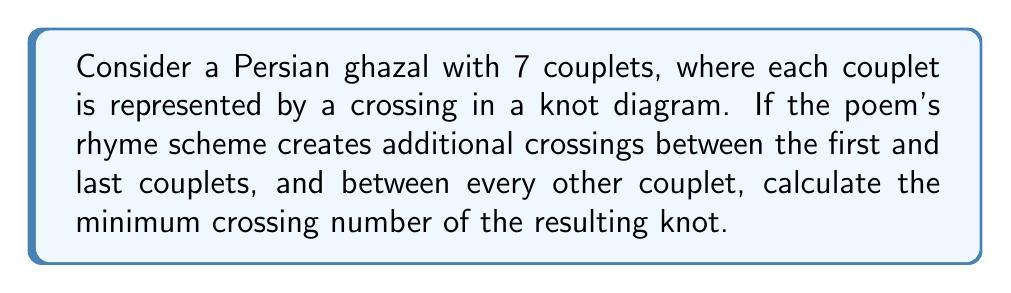Solve this math problem. Let's approach this step-by-step:

1) First, we need to understand the structure of the knot based on the poem:
   - There are 7 couplets, each represented by a crossing.
   - Additional crossings occur between the first and last couplets, and between every other couplet.

2) Let's count the crossings:
   - 7 crossings from the couplets themselves.
   - 1 crossing between the first and last couplet.
   - Crossings between every other couplet:
     There are 3 such additional crossings (1-3, 3-5, 5-7).

3) So far, we have: $7 + 1 + 3 = 11$ crossings.

4) However, the question asks for the minimum crossing number. In knot theory, the minimum crossing number is the smallest number of crossings that can be achieved for a given knot through any possible deformation without cutting the knot.

5) In this case, the structure of the poem creates a relatively simple knot. The crossings between every other couplet can be visualized as creating a spiral-like structure.

6) Given this structure, it's possible that some crossings could be eliminated through careful deformation. However, the specific structure (connecting first and last couplets, and every other couplet) suggests that significant reduction is unlikely without fundamentally changing the knot.

7) Therefore, while there might be some small reduction possible, the minimum crossing number is likely to be very close to our initial count of 11.

8) Without a more detailed geometric analysis, we can reasonably estimate the minimum crossing number to be between 9 and 11.

9) For the purposes of this problem, given the information provided, we'll consider 11 as our best estimate for the minimum crossing number.
Answer: 11 